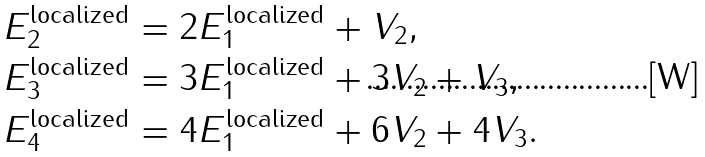Convert formula to latex. <formula><loc_0><loc_0><loc_500><loc_500>E _ { 2 } ^ { \text {localized} } & = 2 E _ { 1 } ^ { \text {localized} } + V _ { 2 } , \\ E _ { 3 } ^ { \text {localized} } & = 3 E _ { 1 } ^ { \text {localized} } + 3 V _ { 2 } + V _ { 3 } , \\ E _ { 4 } ^ { \text {localized} } & = 4 E _ { 1 } ^ { \text {localized} } + 6 V _ { 2 } + 4 V _ { 3 } .</formula> 